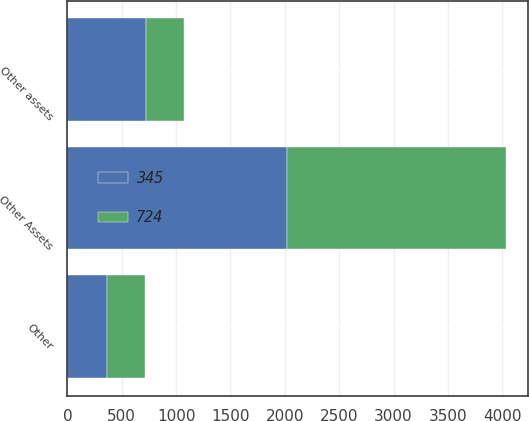Convert chart to OTSL. <chart><loc_0><loc_0><loc_500><loc_500><stacked_bar_chart><ecel><fcel>Other Assets<fcel>Other<fcel>Other assets<nl><fcel>345<fcel>2018<fcel>369<fcel>724<nl><fcel>724<fcel>2017<fcel>345<fcel>345<nl></chart> 